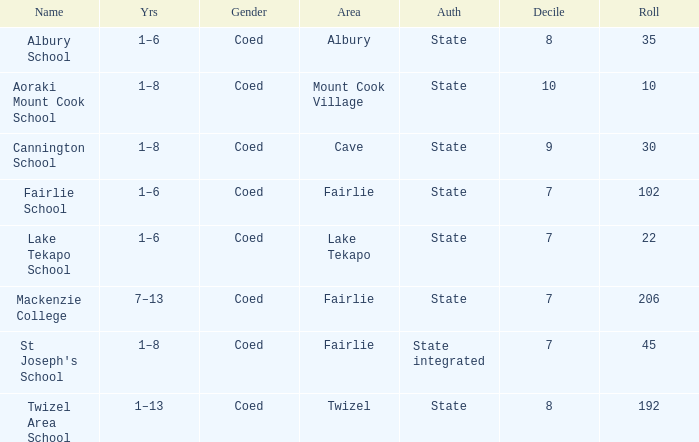What area is named Mackenzie college? Fairlie. 